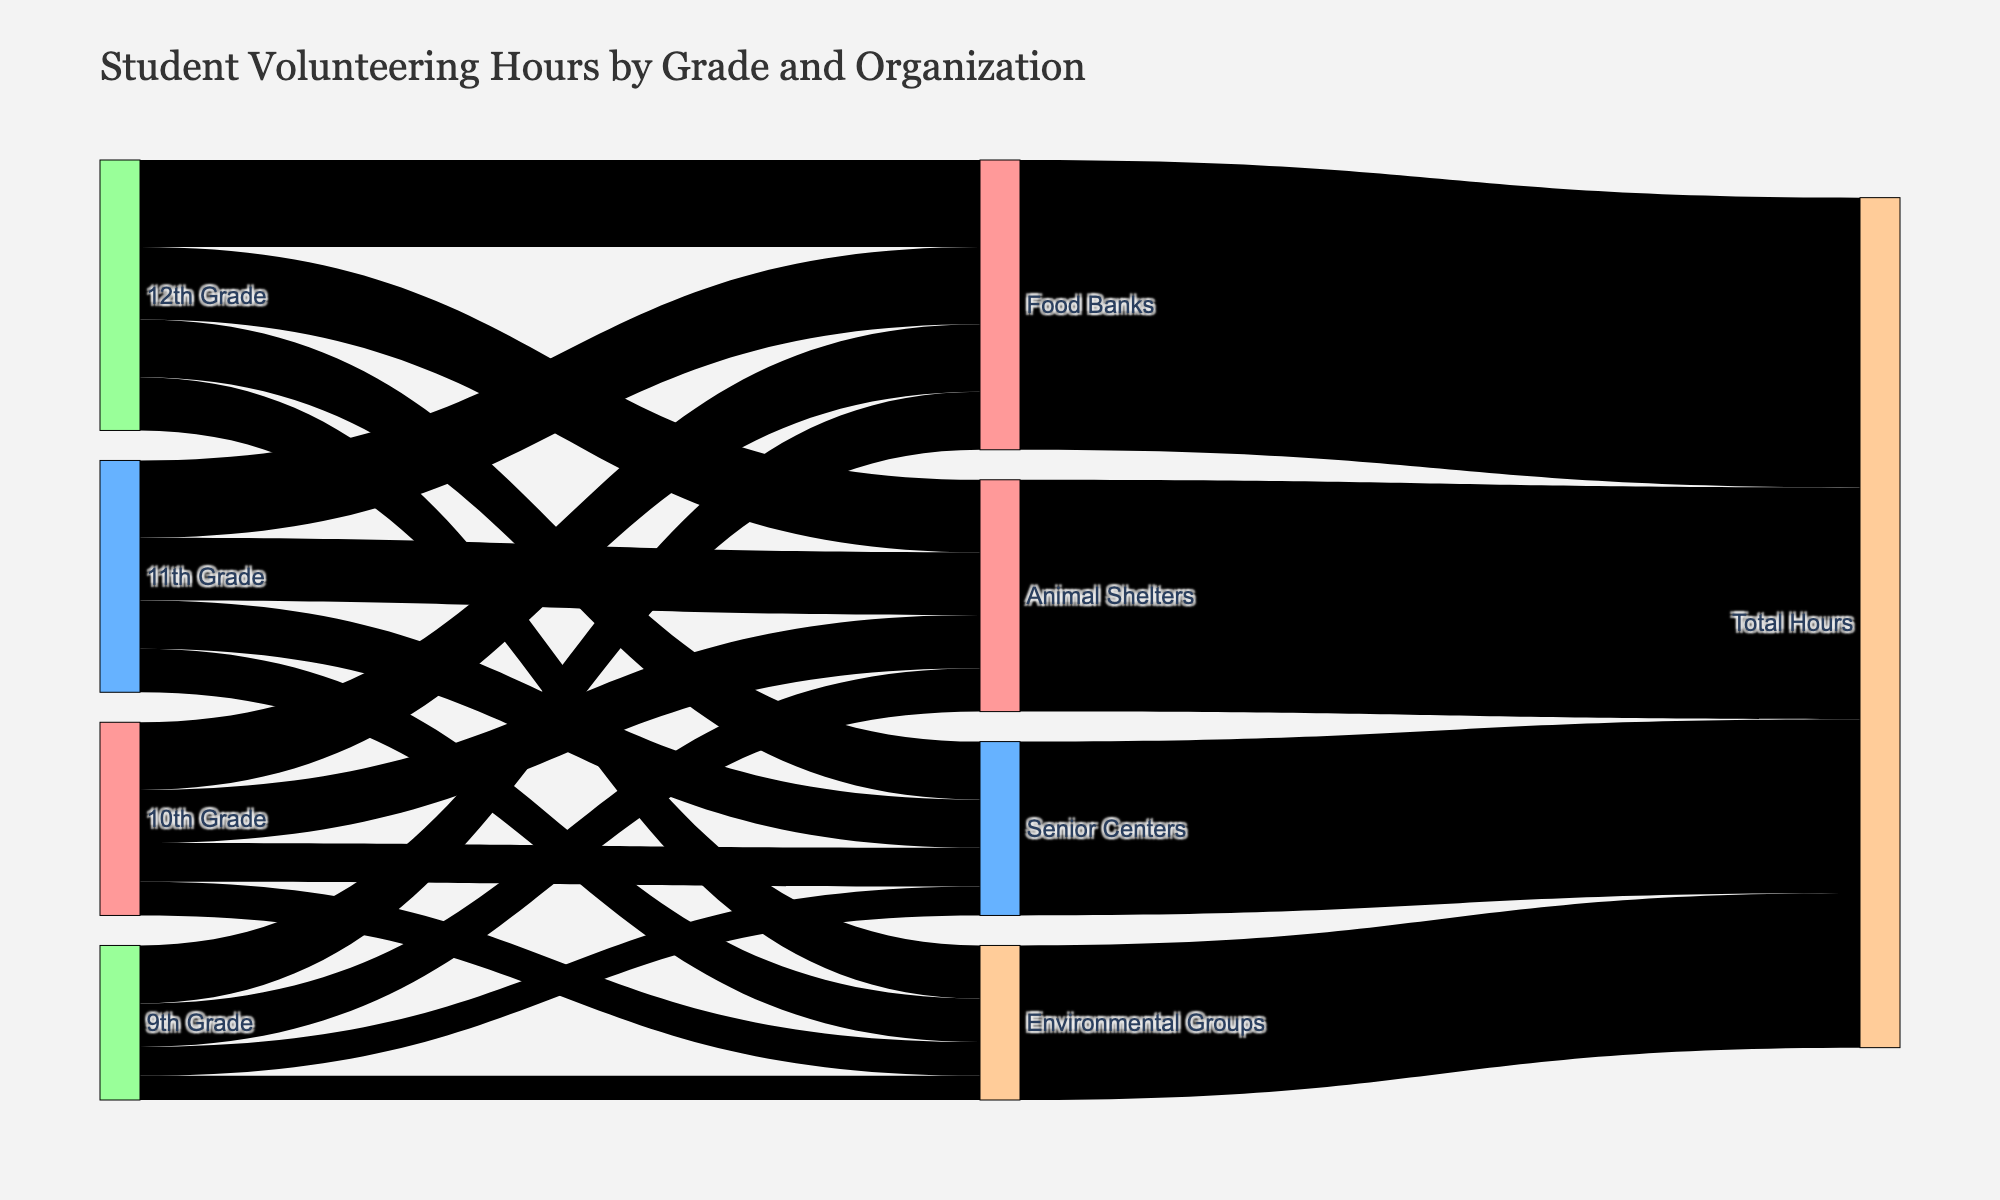What's the title of the figure? The title is prominently displayed at the top of the figure, indicating the main topic of the visualization.
Answer: Student Volunteering Hours by Grade and Organization What type of organization received the most volunteering hours from 12th-grade students? By following the flow from "12th Grade" to each type of organization, we observe that "Food Banks" has the thickest link indicating the highest number of volunteering hours.
Answer: Food Banks How many total volunteering hours were contributed to Senior Centers? Total hours for each type of organization are summarized at the end nodes. The node labeled "Senior Centers" connects with 180 total hours.
Answer: 180 What is the difference in volunteering hours between Food Banks and Environmental Groups for 11th-grade students? For the 11th Grade, the hours for Food Banks are 80 and for Environmental Groups are 45. Subtracting 45 from 80 gives the difference.
Answer: 35 Which grade level contributed the highest number of hours to Animal Shelters? By comparing the thickness of the links connecting each grade level to "Animal Shelters," the thickest link belongs to the 12th Grade.
Answer: 12th Grade What is the average number of hours contributed to Environmental Groups by all grades? Calculate the total hours contributed by each grade to Environmental Groups (25+35+45+55 = 160). Then divide by the number of grades (4).
Answer: 40 Which organization received the least amount of total volunteering hours? Check the final nodes indicating total hours for each organization. The node with the smallest value is "Environmental Groups" with 160 hours.
Answer: Environmental Groups How do the volunteering hours for 9th and 10th grades compare for Food Banks? Compare the links connecting 9th Grade and 10th Grade to "Food Banks," and see that 10th Grade contributed 70 hours, which is higher than 9th Grade's 60 hours.
Answer: 10th Grade contributed more What's the combined total of volunteering hours to Food Banks from all grades? Add the hours from all grades for Food Banks: 60 (9th) + 70 (10th) + 80 (11th) + 90 (12th) = 300.
Answer: 300 What is the highest number of hours contributed by any grade level to any type of organization? The thickest link from any grade level to any organization represents the highest hours; here, it's the 90 hours contributed by 12th Grade to Food Banks.
Answer: 90 